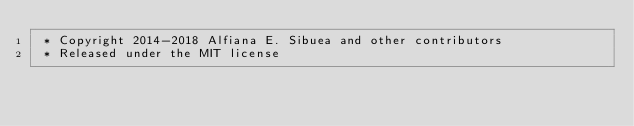<code> <loc_0><loc_0><loc_500><loc_500><_CSS_> * Copyright 2014-2018 Alfiana E. Sibuea and other contributors 
 * Released under the MIT license </code> 